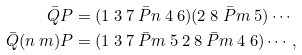<formula> <loc_0><loc_0><loc_500><loc_500>\bar { Q } P & = ( 1 \ 3 \ 7 \ \bar { P } n \ 4 \ 6 ) ( 2 \ 8 \ \bar { P } m \ 5 ) \cdots \\ \bar { Q } ( n \ m ) P & = ( 1 \ 3 \ 7 \ \bar { P } m \ 5 \ 2 \ 8 \ \bar { P } m \ 4 \ 6 ) \cdots ,</formula> 